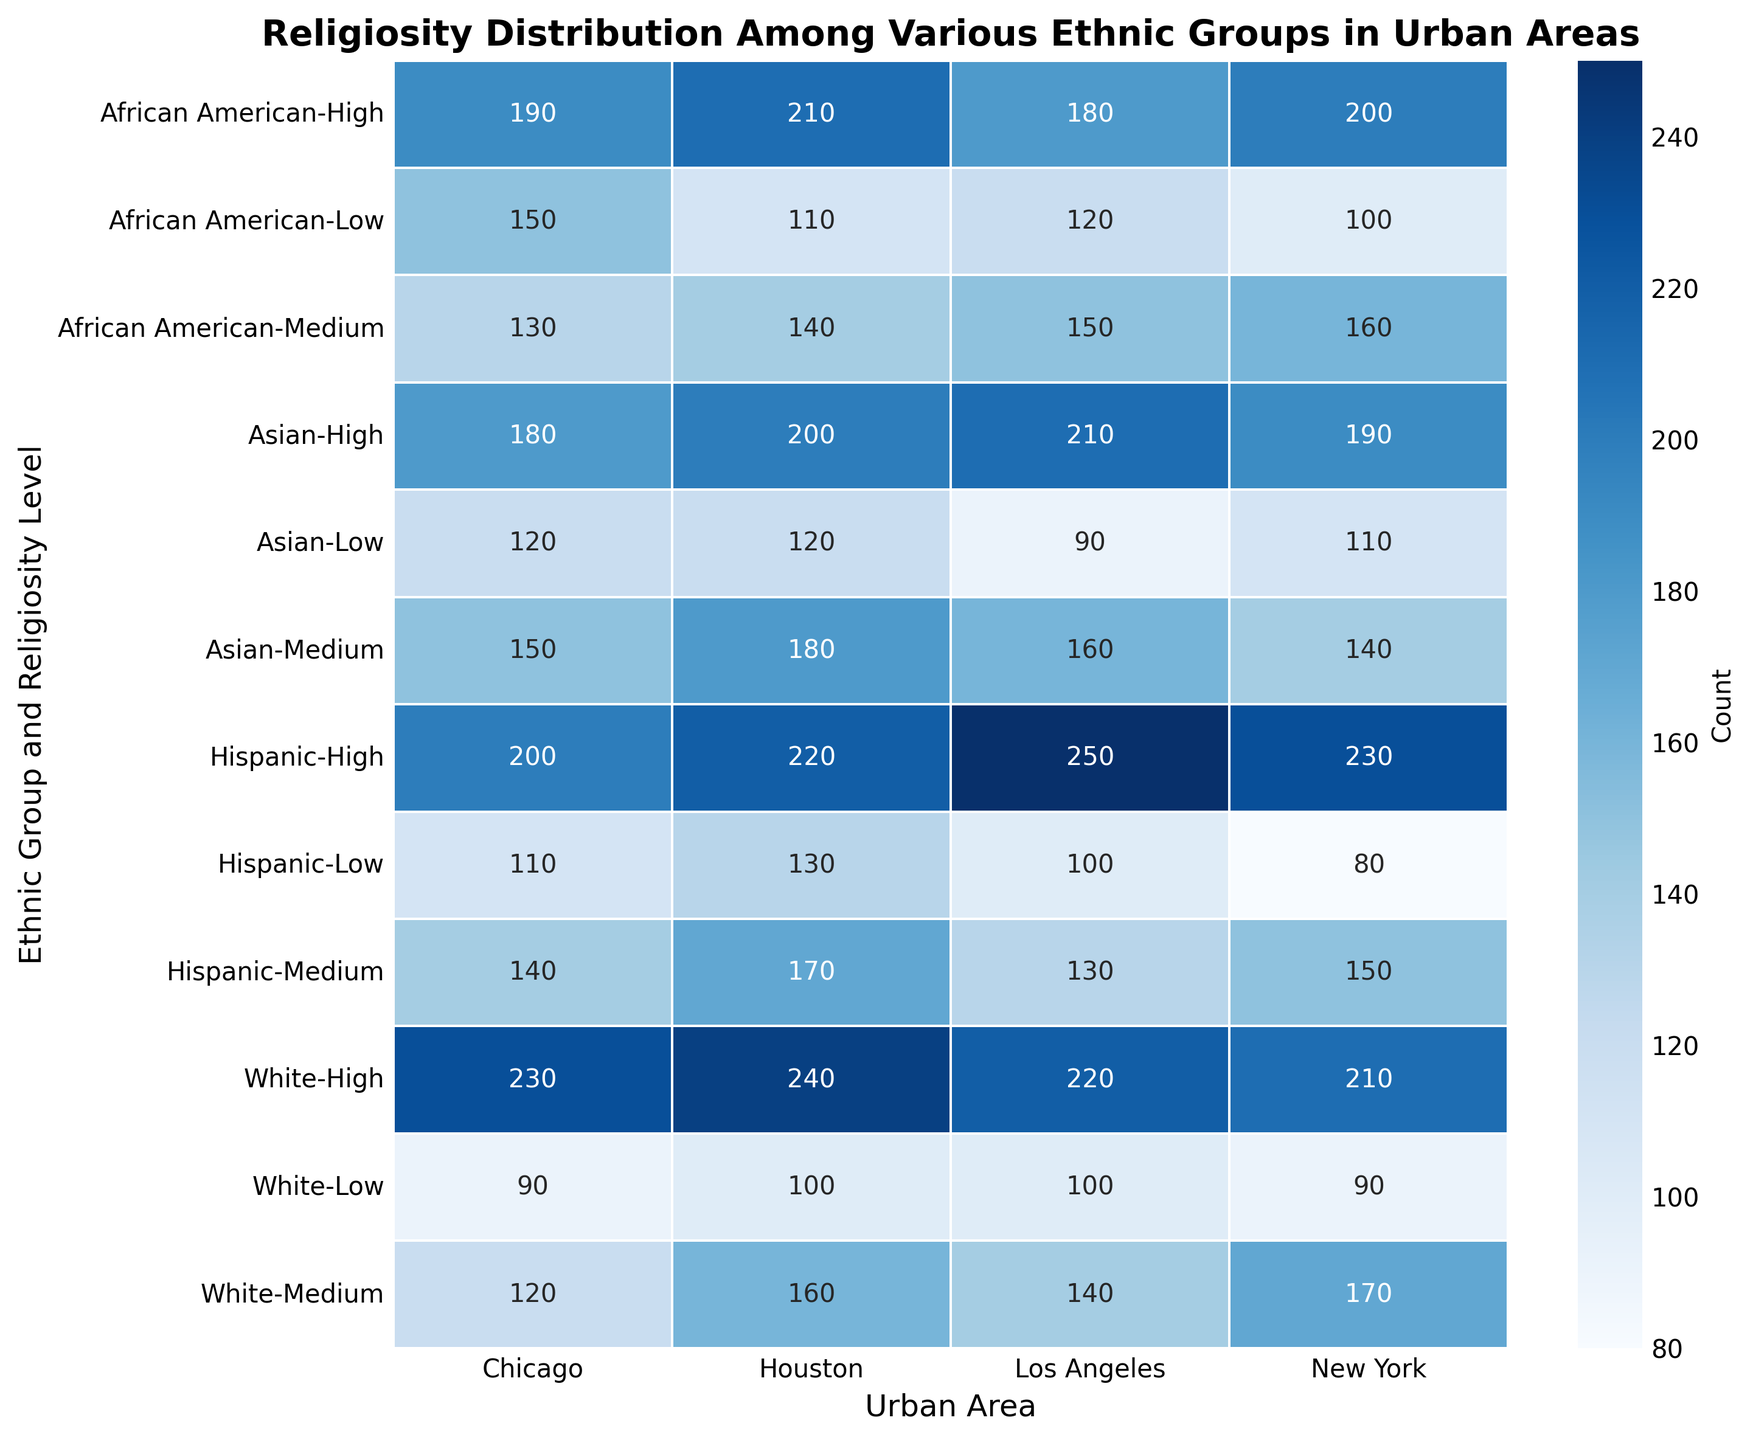What is the total count of individuals with a high religiosity level across all ethnic groups in New York? First, find the count for each ethnic group in New York with a high religiosity level: Hispanic (230), African American (200), Asian (190), and White (210). Sum these counts: 230 + 200 + 190 + 210 = 830.
Answer: 830 Which ethnic group has the lowest number of individuals with medium religiosity in Chicago? Look at the counts for medium religiosity in Chicago across all ethnic groups: Hispanic (140), African American (130), Asian (150), and White (120). The lowest count is for White (120).
Answer: White How does the number of Asians with a low religiosity level in Los Angeles compare to those with a high religiosity level in Chicago? The count for Asians with low religiosity in Los Angeles is 90, and the count for Asians with high religiosity in Chicago is 180. The number in Los Angeles is lower.
Answer: Lower What is the average number of individuals with medium religiosity across all ethnic groups in Houston? Find the counts for medium religiosity in Houston for each ethnic group: Hispanic (170), African American (140), Asian (180), and White (160). Sum these counts: 170 + 140 + 180 + 160 = 650. Divide by the number of ethnic groups (4): 650 / 4 = 162.5.
Answer: 162.5 Which urban area has the highest number of individuals with a low religiosity level among African Americans? Compare the counts for African Americans with low religiosity across all urban areas: New York (100), Los Angeles (120), Chicago (150), and Houston (110). Chicago has the highest count (150).
Answer: Chicago Is the number of Hispanics with high religiosity in Los Angeles greater than the number of Whites with high religiosity in Houston? The count for Hispanics with high religiosity in Los Angeles is 250, and the count for Whites with high religiosity in Houston is 240. The number in Los Angeles is greater.
Answer: Greater What is the difference between the number of Whites with medium religiosity in New York and Los Angeles? Find the counts for Whites with medium religiosity in New York (170) and Los Angeles (140). Calculate the difference: 170 - 140 = 30.
Answer: 30 Which religiosity level has the darkest color on the heatmap for Asian individuals in Houston? On the heatmap, the color intensity increases with the count. For Asian individuals in Houston, the counts are high (200), medium (180), and low (120). The darkest color corresponds to the highest count, which is the high religiosity level (200).
Answer: High 